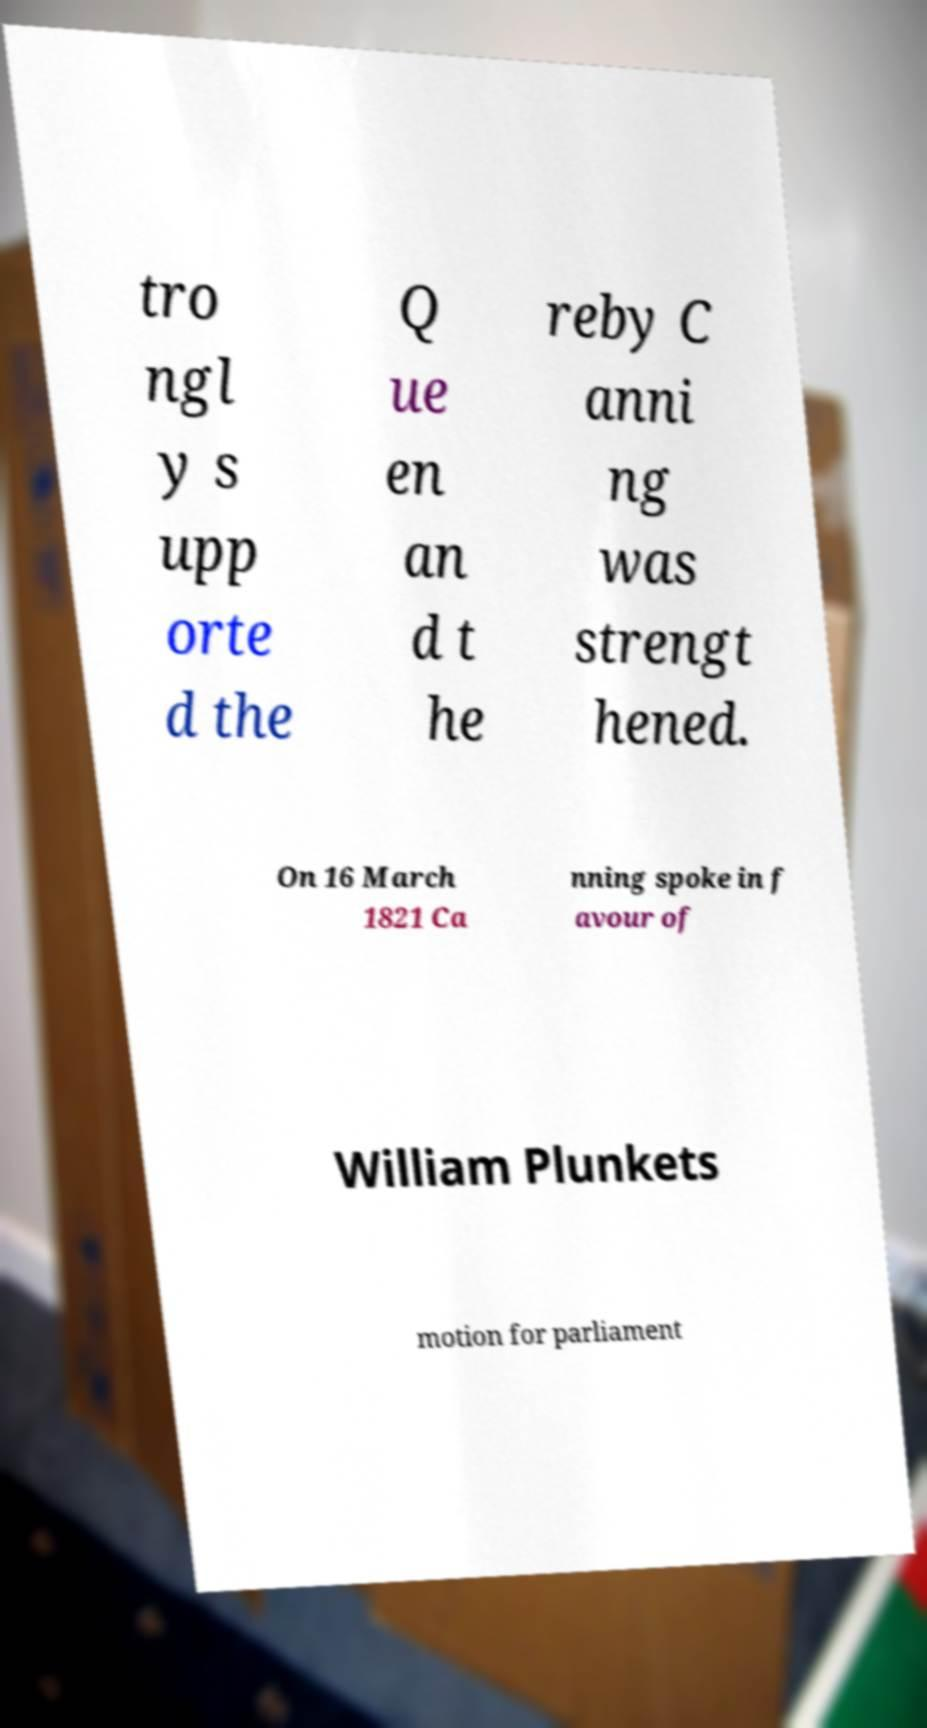Can you read and provide the text displayed in the image?This photo seems to have some interesting text. Can you extract and type it out for me? tro ngl y s upp orte d the Q ue en an d t he reby C anni ng was strengt hened. On 16 March 1821 Ca nning spoke in f avour of William Plunkets motion for parliament 